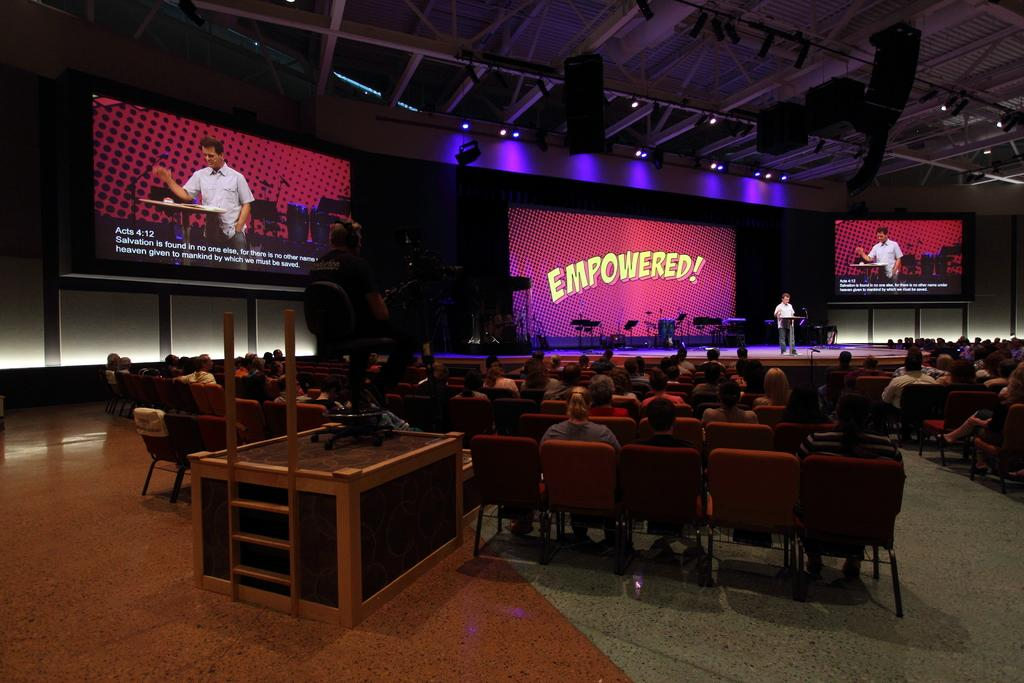What is happening in the image? There are people at an event. What can be seen on the stage? A man is on stage. What is behind the man on stage? There is a large screen behind the man on stage. What type of slave is depicted in the image? There is no slave depicted in the image; it features people at an event with a man on stage and a large screen behind him. What type of lawyer is present in the image? There is no lawyer present in the image; it features people at an event with a man on stage and a large screen behind him. 